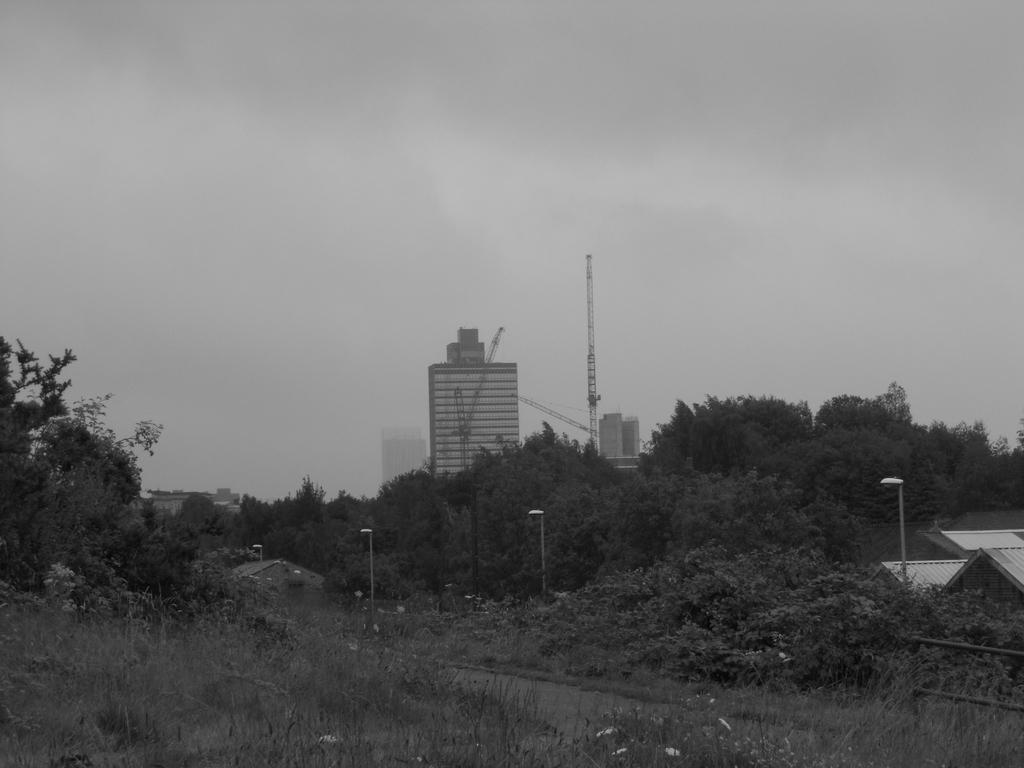In one or two sentences, can you explain what this image depicts? In this image there are grass, bushes, trees, lamp posts and buildings. 